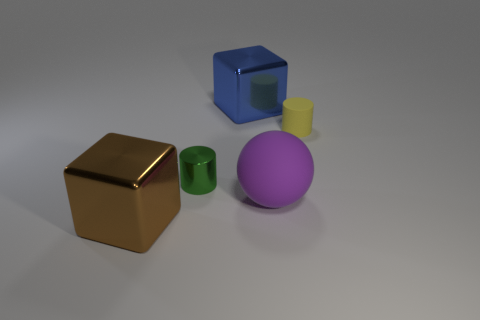How many things are both in front of the yellow cylinder and left of the purple rubber ball?
Provide a succinct answer. 2. What is the small green thing made of?
Keep it short and to the point. Metal. Are the tiny yellow cylinder and the big blue cube made of the same material?
Give a very brief answer. No. There is a big shiny cube that is in front of the block that is right of the metal cylinder; what number of blue things are right of it?
Offer a very short reply. 1. What number of blue metallic cylinders are there?
Keep it short and to the point. 0. Are there fewer large shiny blocks that are behind the large ball than objects that are on the right side of the big brown block?
Ensure brevity in your answer.  Yes. Is the number of big purple spheres that are in front of the brown block less than the number of blue cubes?
Provide a succinct answer. Yes. What material is the small yellow cylinder that is behind the big metallic object that is to the left of the big shiny object that is to the right of the large brown block?
Give a very brief answer. Rubber. What number of objects are either shiny cubes that are in front of the purple thing or metallic cubes behind the big brown metallic cube?
Keep it short and to the point. 2. There is another small yellow thing that is the same shape as the tiny metal thing; what material is it?
Keep it short and to the point. Rubber. 